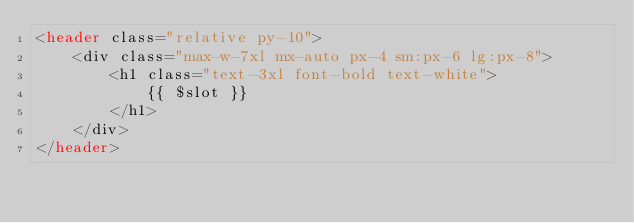Convert code to text. <code><loc_0><loc_0><loc_500><loc_500><_PHP_><header class="relative py-10">
    <div class="max-w-7xl mx-auto px-4 sm:px-6 lg:px-8">
        <h1 class="text-3xl font-bold text-white">
            {{ $slot }}
        </h1>
    </div>
</header>
</code> 